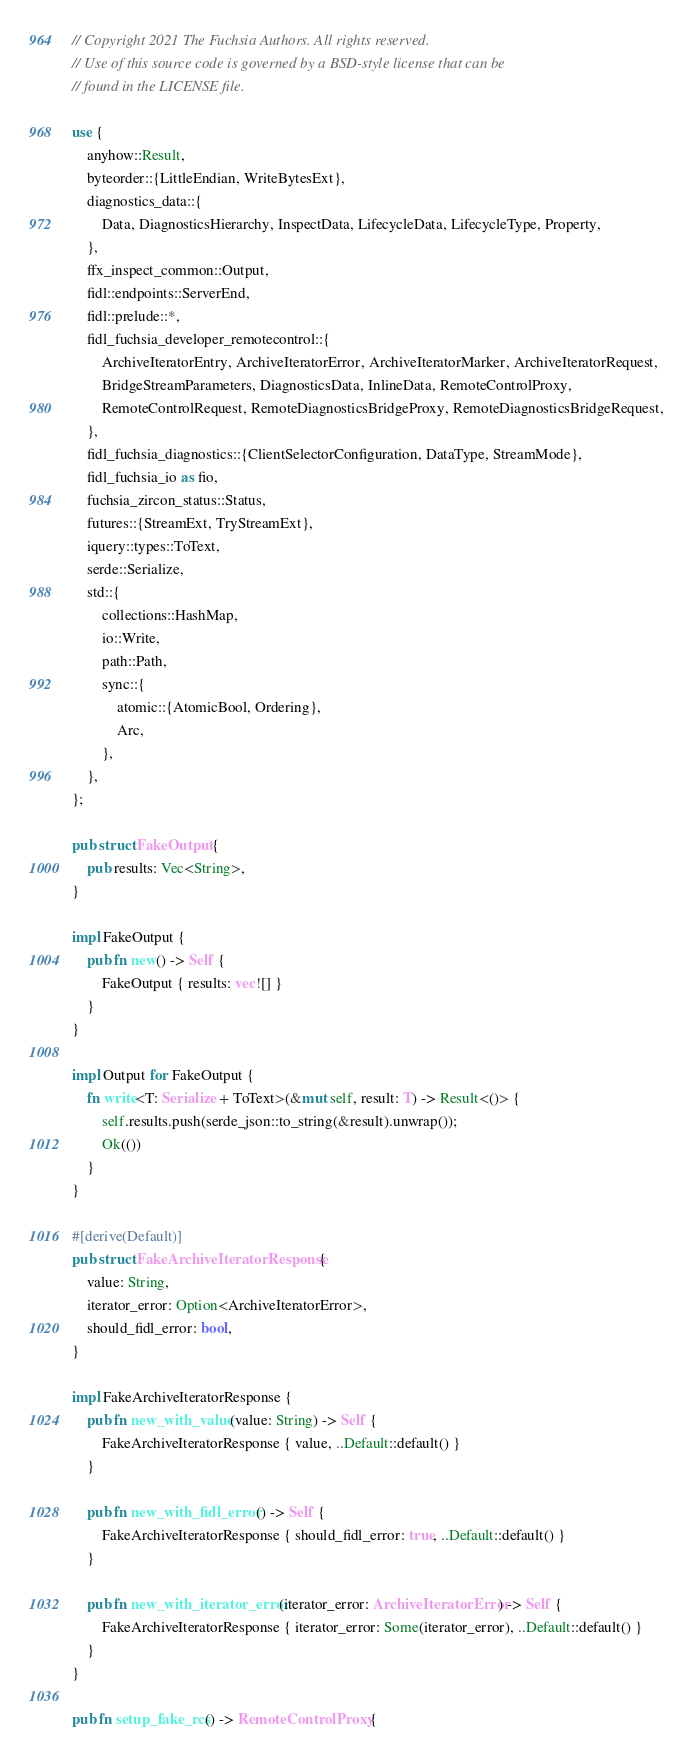<code> <loc_0><loc_0><loc_500><loc_500><_Rust_>// Copyright 2021 The Fuchsia Authors. All rights reserved.
// Use of this source code is governed by a BSD-style license that can be
// found in the LICENSE file.

use {
    anyhow::Result,
    byteorder::{LittleEndian, WriteBytesExt},
    diagnostics_data::{
        Data, DiagnosticsHierarchy, InspectData, LifecycleData, LifecycleType, Property,
    },
    ffx_inspect_common::Output,
    fidl::endpoints::ServerEnd,
    fidl::prelude::*,
    fidl_fuchsia_developer_remotecontrol::{
        ArchiveIteratorEntry, ArchiveIteratorError, ArchiveIteratorMarker, ArchiveIteratorRequest,
        BridgeStreamParameters, DiagnosticsData, InlineData, RemoteControlProxy,
        RemoteControlRequest, RemoteDiagnosticsBridgeProxy, RemoteDiagnosticsBridgeRequest,
    },
    fidl_fuchsia_diagnostics::{ClientSelectorConfiguration, DataType, StreamMode},
    fidl_fuchsia_io as fio,
    fuchsia_zircon_status::Status,
    futures::{StreamExt, TryStreamExt},
    iquery::types::ToText,
    serde::Serialize,
    std::{
        collections::HashMap,
        io::Write,
        path::Path,
        sync::{
            atomic::{AtomicBool, Ordering},
            Arc,
        },
    },
};

pub struct FakeOutput {
    pub results: Vec<String>,
}

impl FakeOutput {
    pub fn new() -> Self {
        FakeOutput { results: vec![] }
    }
}

impl Output for FakeOutput {
    fn write<T: Serialize + ToText>(&mut self, result: T) -> Result<()> {
        self.results.push(serde_json::to_string(&result).unwrap());
        Ok(())
    }
}

#[derive(Default)]
pub struct FakeArchiveIteratorResponse {
    value: String,
    iterator_error: Option<ArchiveIteratorError>,
    should_fidl_error: bool,
}

impl FakeArchiveIteratorResponse {
    pub fn new_with_value(value: String) -> Self {
        FakeArchiveIteratorResponse { value, ..Default::default() }
    }

    pub fn new_with_fidl_error() -> Self {
        FakeArchiveIteratorResponse { should_fidl_error: true, ..Default::default() }
    }

    pub fn new_with_iterator_error(iterator_error: ArchiveIteratorError) -> Self {
        FakeArchiveIteratorResponse { iterator_error: Some(iterator_error), ..Default::default() }
    }
}

pub fn setup_fake_rcs() -> RemoteControlProxy {</code> 